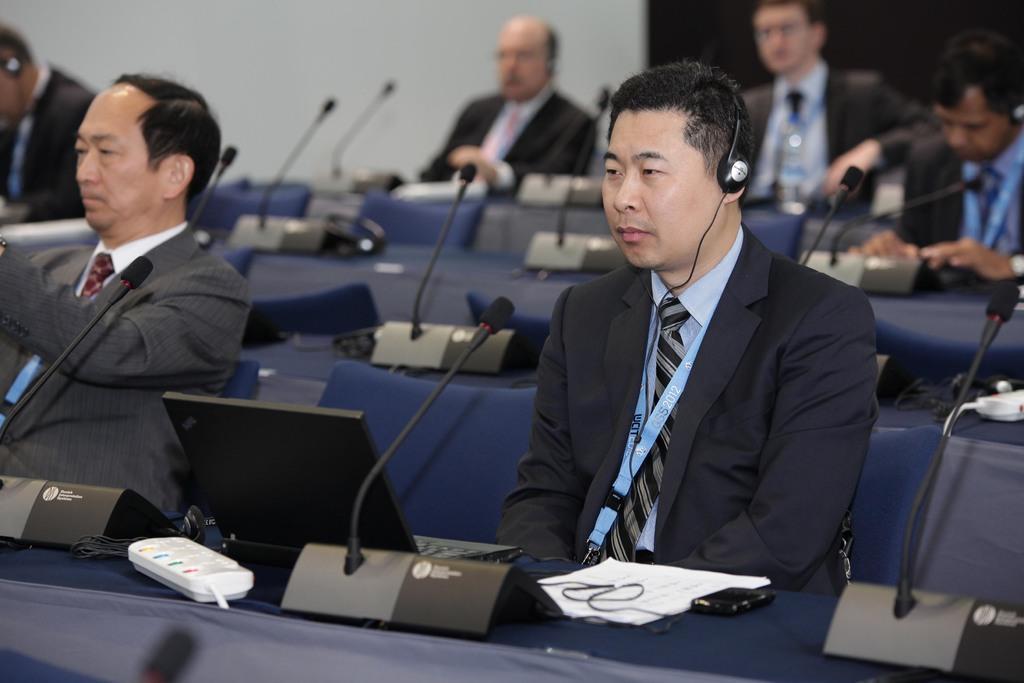Could you give a brief overview of what you see in this image? In this image we can see some persons wearing suits sitting and there are some microphones, water bottles, some other items and in the background of the image there is a wall. 